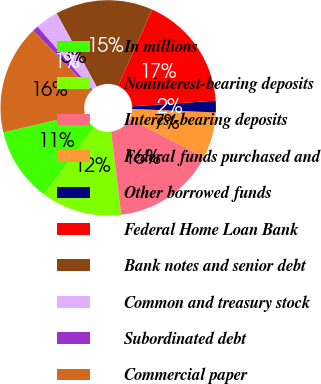Convert chart. <chart><loc_0><loc_0><loc_500><loc_500><pie_chart><fcel>In millions<fcel>Noninterest-bearing deposits<fcel>Interest-bearing deposits<fcel>Federal funds purchased and<fcel>Other borrowed funds<fcel>Federal Home Loan Bank<fcel>Bank notes and senior debt<fcel>Common and treasury stock<fcel>Subordinated debt<fcel>Commercial paper<nl><fcel>11.21%<fcel>12.07%<fcel>15.51%<fcel>6.9%<fcel>1.73%<fcel>17.24%<fcel>14.65%<fcel>3.45%<fcel>0.87%<fcel>16.38%<nl></chart> 